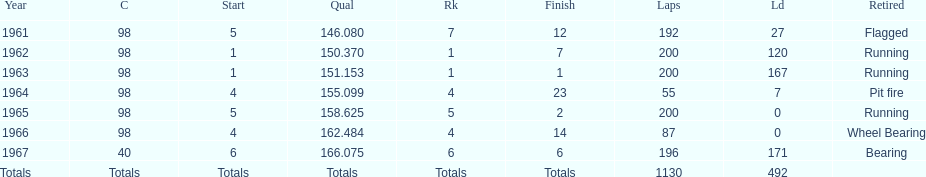What was his best finish before his first win? 7. 